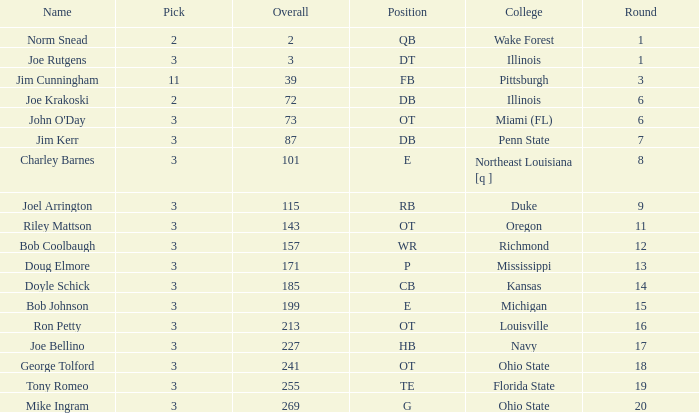How many rounds have john o'day as the name, and a pick less than 3? None. 